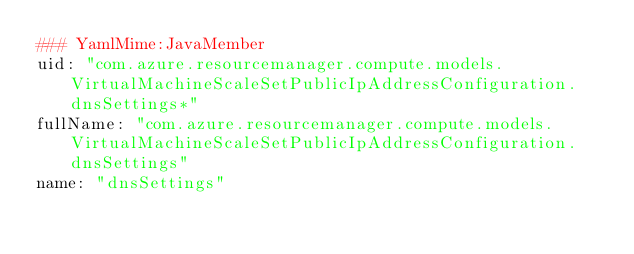<code> <loc_0><loc_0><loc_500><loc_500><_YAML_>### YamlMime:JavaMember
uid: "com.azure.resourcemanager.compute.models.VirtualMachineScaleSetPublicIpAddressConfiguration.dnsSettings*"
fullName: "com.azure.resourcemanager.compute.models.VirtualMachineScaleSetPublicIpAddressConfiguration.dnsSettings"
name: "dnsSettings"</code> 